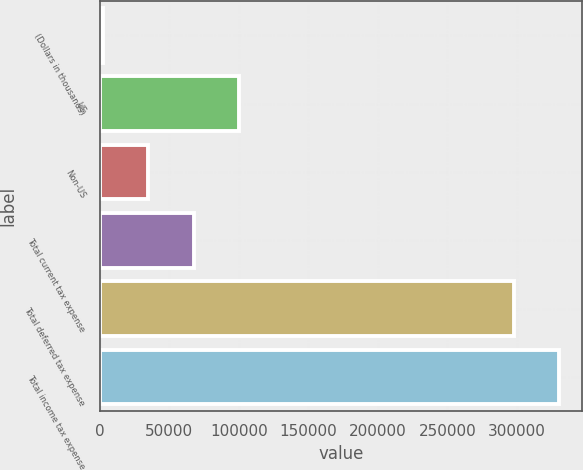Convert chart to OTSL. <chart><loc_0><loc_0><loc_500><loc_500><bar_chart><fcel>(Dollars in thousands)<fcel>US<fcel>Non-US<fcel>Total current tax expense<fcel>Total deferred tax expense<fcel>Total income tax expense<nl><fcel>2018<fcel>100420<fcel>34818.5<fcel>67619<fcel>297895<fcel>330696<nl></chart> 